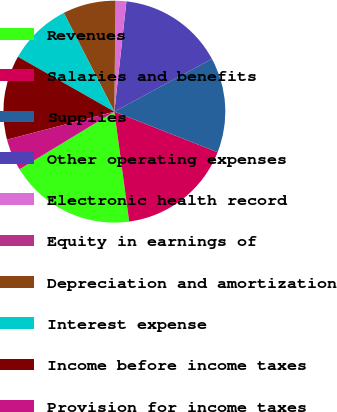<chart> <loc_0><loc_0><loc_500><loc_500><pie_chart><fcel>Revenues<fcel>Salaries and benefits<fcel>Supplies<fcel>Other operating expenses<fcel>Electronic health record<fcel>Equity in earnings of<fcel>Depreciation and amortization<fcel>Interest expense<fcel>Income before income taxes<fcel>Provision for income taxes<nl><fcel>18.45%<fcel>16.91%<fcel>13.84%<fcel>15.38%<fcel>1.55%<fcel>0.02%<fcel>7.7%<fcel>9.23%<fcel>12.3%<fcel>4.62%<nl></chart> 